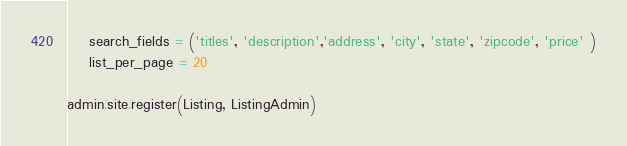<code> <loc_0><loc_0><loc_500><loc_500><_Python_>    search_fields = ('titles', 'description','address', 'city', 'state', 'zipcode', 'price' )
    list_per_page = 20

admin.site.register(Listing, ListingAdmin)
</code> 